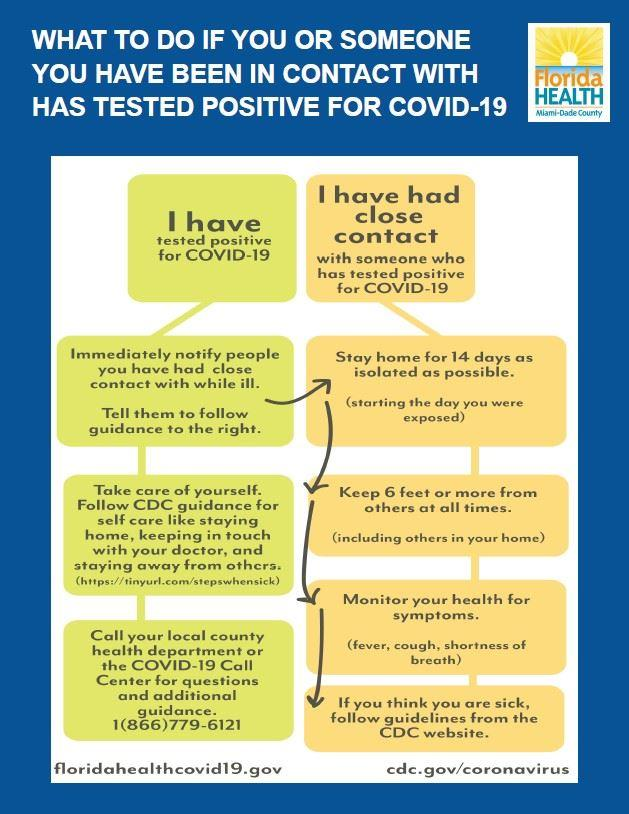Indicate a few pertinent items in this graphic. During the period of quarantine, it is recommended to maintain a distance of at least 6 feet or more from others to prevent the spread of COVID-19. After informing others and receiving a positive Covid-19 diagnosis, it is necessary to stay at home for a period of 14 days to minimize the risk of spreading the virus and to maintain personal safety. On the day of exposure to COVID-19, one should enter the quarantine period. If someone believes they are not well due to COVID-19, they should follow the guidelines provided by the Centers for Disease Control and Prevention on their website. The color code assigned to the person who has primary contact with a Covid-19 positive patient is yellow. 